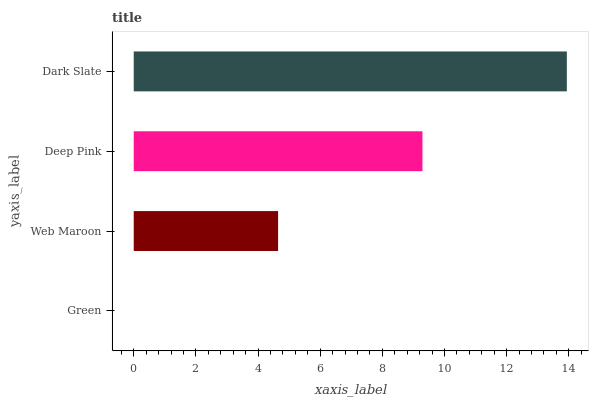Is Green the minimum?
Answer yes or no. Yes. Is Dark Slate the maximum?
Answer yes or no. Yes. Is Web Maroon the minimum?
Answer yes or no. No. Is Web Maroon the maximum?
Answer yes or no. No. Is Web Maroon greater than Green?
Answer yes or no. Yes. Is Green less than Web Maroon?
Answer yes or no. Yes. Is Green greater than Web Maroon?
Answer yes or no. No. Is Web Maroon less than Green?
Answer yes or no. No. Is Deep Pink the high median?
Answer yes or no. Yes. Is Web Maroon the low median?
Answer yes or no. Yes. Is Web Maroon the high median?
Answer yes or no. No. Is Green the low median?
Answer yes or no. No. 